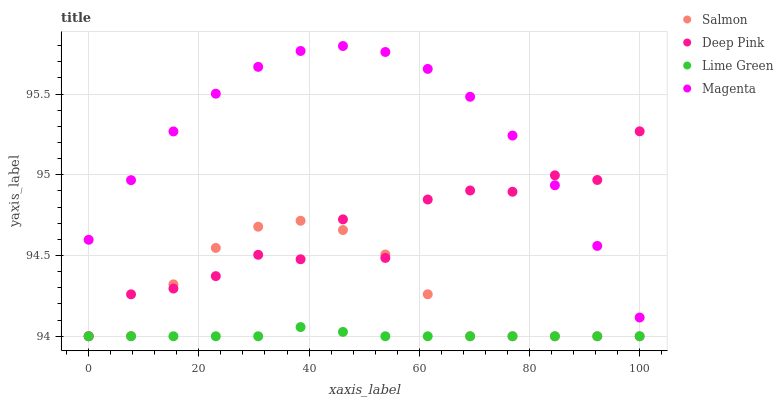Does Lime Green have the minimum area under the curve?
Answer yes or no. Yes. Does Magenta have the maximum area under the curve?
Answer yes or no. Yes. Does Deep Pink have the minimum area under the curve?
Answer yes or no. No. Does Deep Pink have the maximum area under the curve?
Answer yes or no. No. Is Lime Green the smoothest?
Answer yes or no. Yes. Is Deep Pink the roughest?
Answer yes or no. Yes. Is Magenta the smoothest?
Answer yes or no. No. Is Magenta the roughest?
Answer yes or no. No. Does Lime Green have the lowest value?
Answer yes or no. Yes. Does Magenta have the lowest value?
Answer yes or no. No. Does Magenta have the highest value?
Answer yes or no. Yes. Does Deep Pink have the highest value?
Answer yes or no. No. Is Salmon less than Magenta?
Answer yes or no. Yes. Is Magenta greater than Salmon?
Answer yes or no. Yes. Does Deep Pink intersect Salmon?
Answer yes or no. Yes. Is Deep Pink less than Salmon?
Answer yes or no. No. Is Deep Pink greater than Salmon?
Answer yes or no. No. Does Salmon intersect Magenta?
Answer yes or no. No. 